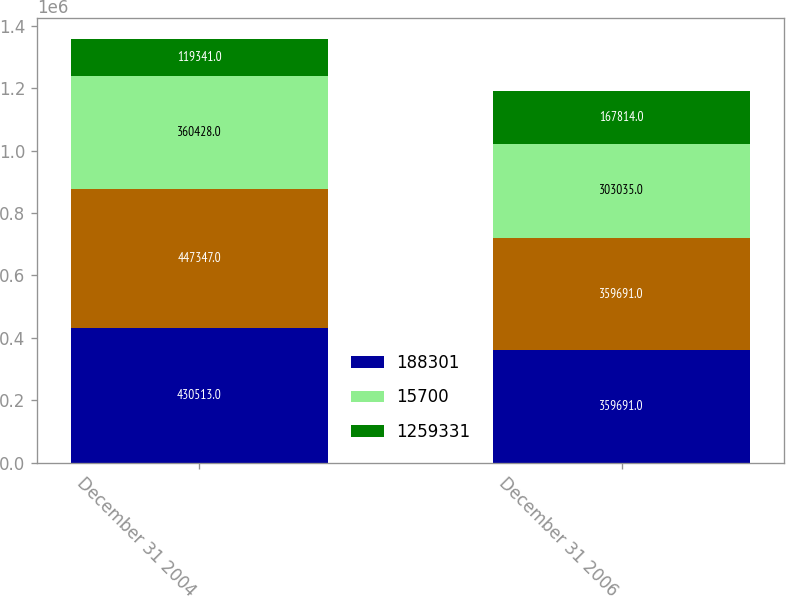<chart> <loc_0><loc_0><loc_500><loc_500><stacked_bar_chart><ecel><fcel>December 31 2004<fcel>December 31 2006<nl><fcel>188301<fcel>430513<fcel>359691<nl><fcel>nan<fcel>447347<fcel>359691<nl><fcel>15700<fcel>360428<fcel>303035<nl><fcel>1.25933e+06<fcel>119341<fcel>167814<nl></chart> 